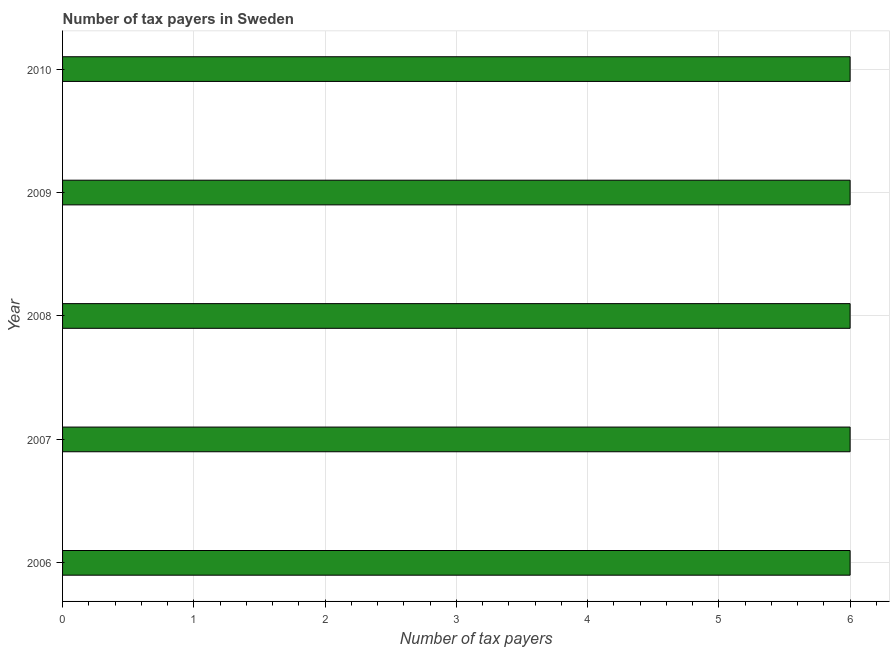Does the graph contain any zero values?
Your answer should be compact. No. What is the title of the graph?
Your answer should be very brief. Number of tax payers in Sweden. What is the label or title of the X-axis?
Provide a short and direct response. Number of tax payers. What is the label or title of the Y-axis?
Give a very brief answer. Year. What is the number of tax payers in 2007?
Your response must be concise. 6. Across all years, what is the minimum number of tax payers?
Offer a terse response. 6. In which year was the number of tax payers maximum?
Ensure brevity in your answer.  2006. In which year was the number of tax payers minimum?
Offer a very short reply. 2006. What is the sum of the number of tax payers?
Your response must be concise. 30. What is the difference between the number of tax payers in 2006 and 2010?
Offer a very short reply. 0. In how many years, is the number of tax payers greater than 2.8 ?
Your answer should be very brief. 5. What is the difference between the highest and the second highest number of tax payers?
Your answer should be very brief. 0. What is the difference between the highest and the lowest number of tax payers?
Keep it short and to the point. 0. In how many years, is the number of tax payers greater than the average number of tax payers taken over all years?
Your response must be concise. 0. How many years are there in the graph?
Your answer should be very brief. 5. What is the difference between two consecutive major ticks on the X-axis?
Your response must be concise. 1. Are the values on the major ticks of X-axis written in scientific E-notation?
Your answer should be compact. No. What is the Number of tax payers in 2007?
Give a very brief answer. 6. What is the Number of tax payers in 2008?
Provide a short and direct response. 6. What is the Number of tax payers of 2009?
Offer a terse response. 6. What is the difference between the Number of tax payers in 2006 and 2007?
Keep it short and to the point. 0. What is the difference between the Number of tax payers in 2006 and 2008?
Your answer should be very brief. 0. What is the difference between the Number of tax payers in 2006 and 2009?
Ensure brevity in your answer.  0. What is the difference between the Number of tax payers in 2006 and 2010?
Offer a very short reply. 0. What is the difference between the Number of tax payers in 2007 and 2009?
Offer a very short reply. 0. What is the difference between the Number of tax payers in 2007 and 2010?
Your response must be concise. 0. What is the difference between the Number of tax payers in 2008 and 2009?
Provide a short and direct response. 0. What is the difference between the Number of tax payers in 2008 and 2010?
Your response must be concise. 0. What is the difference between the Number of tax payers in 2009 and 2010?
Give a very brief answer. 0. What is the ratio of the Number of tax payers in 2007 to that in 2008?
Keep it short and to the point. 1. What is the ratio of the Number of tax payers in 2007 to that in 2010?
Your response must be concise. 1. What is the ratio of the Number of tax payers in 2008 to that in 2009?
Keep it short and to the point. 1. What is the ratio of the Number of tax payers in 2009 to that in 2010?
Keep it short and to the point. 1. 